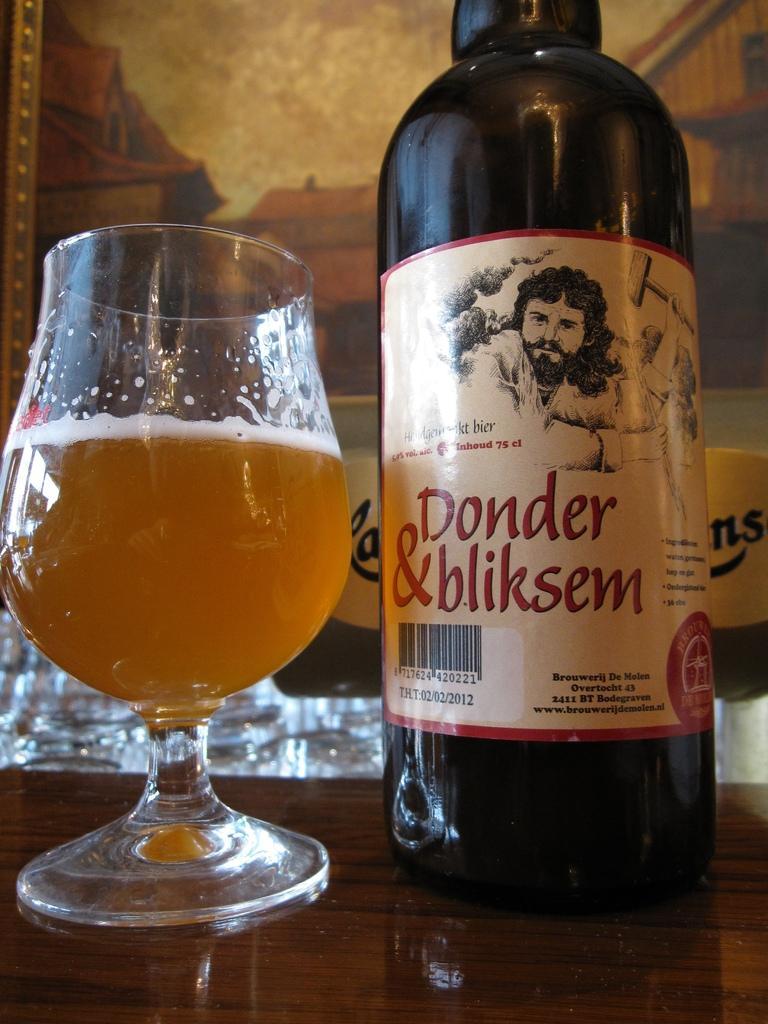Describe this image in one or two sentences. In the picture we can see a glass on the table with wine and beside it, we can see a wine bottle with a label to it. 